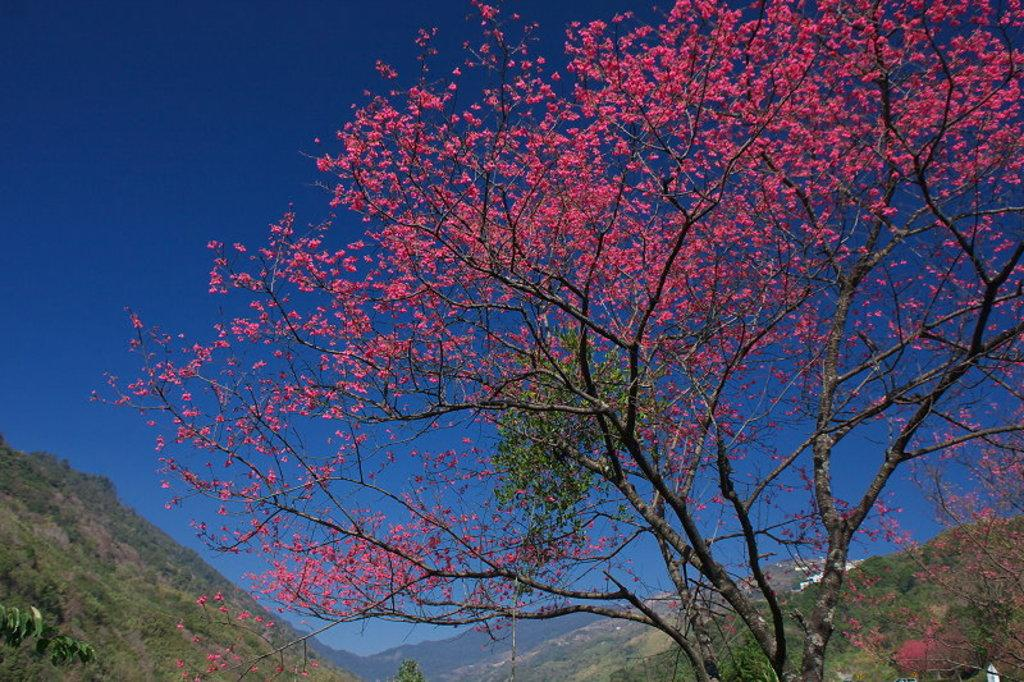What is the main feature of the landscape in the image? There are many mountains in the image. What type of vegetation can be seen on the right side of the image? There are trees on the right side of the image. What is unique about the trees in the center of the image? The trees in the center of the image have pink color leaves. What is visible at the top of the image? The sky is visible at the top of the image. Where is the hen positioned in the image? There is no hen present in the image. How many times do the mountains smash into each other in the image? The mountains do not smash into each other in the image; they are stationary landforms. 